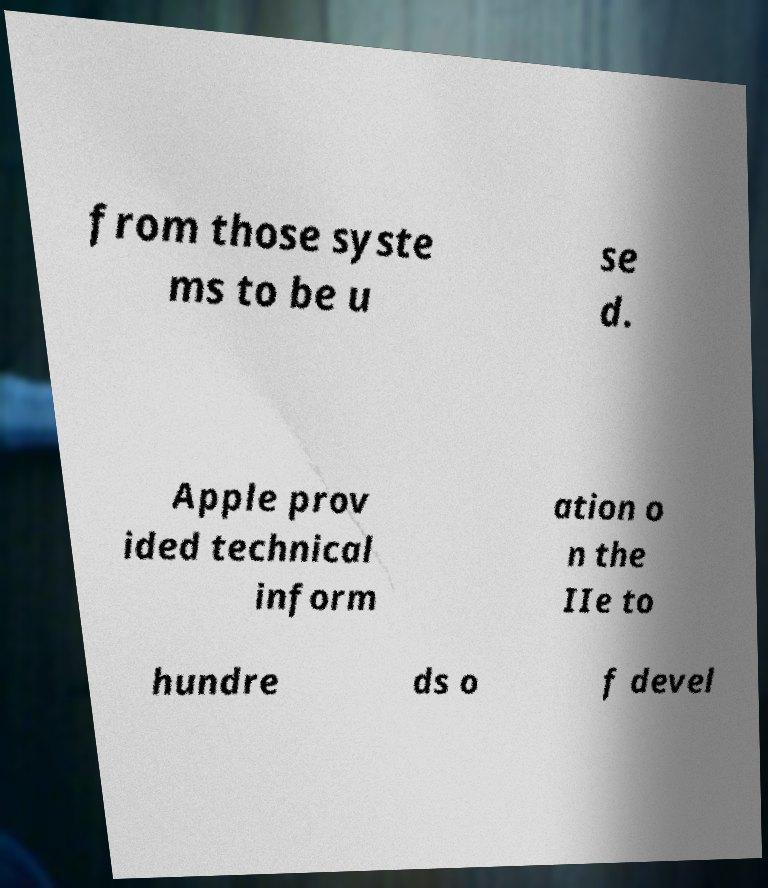Please identify and transcribe the text found in this image. from those syste ms to be u se d. Apple prov ided technical inform ation o n the IIe to hundre ds o f devel 